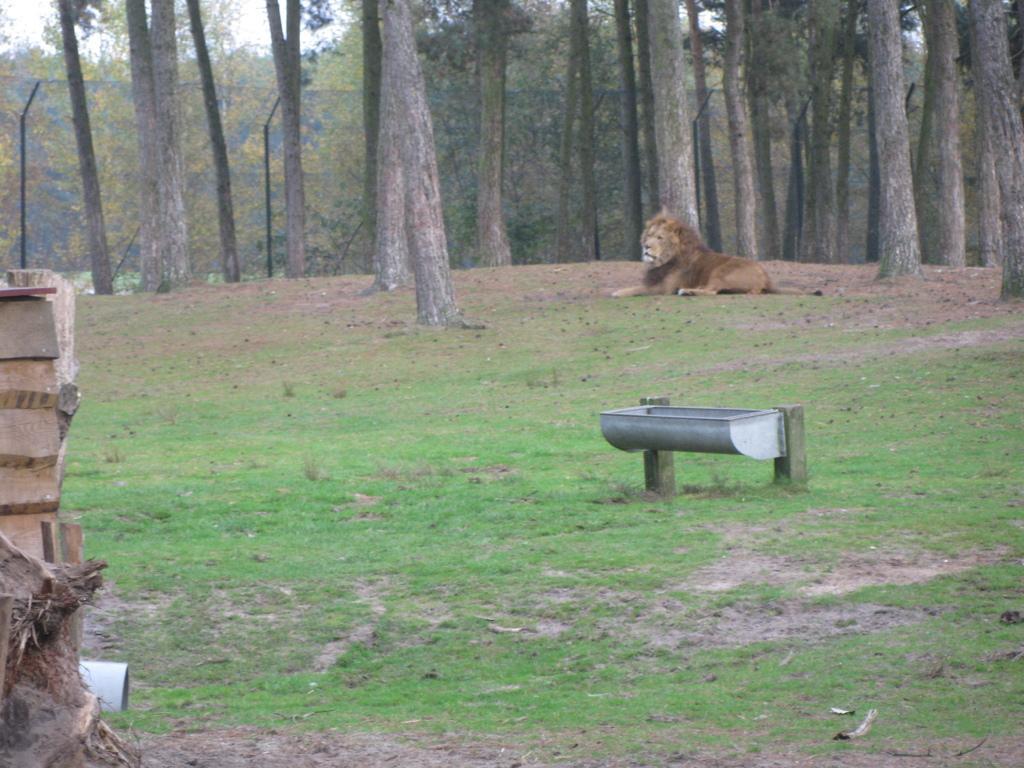In one or two sentences, can you explain what this image depicts? This image looks like it is clicked in a zoo. The image consists of a lion sitting on the ground. On the left, there is a wall. In the background, there are many trees and a fencing. At the bottom, there is green grass. In the middle, we can see a tub made up of metal. 